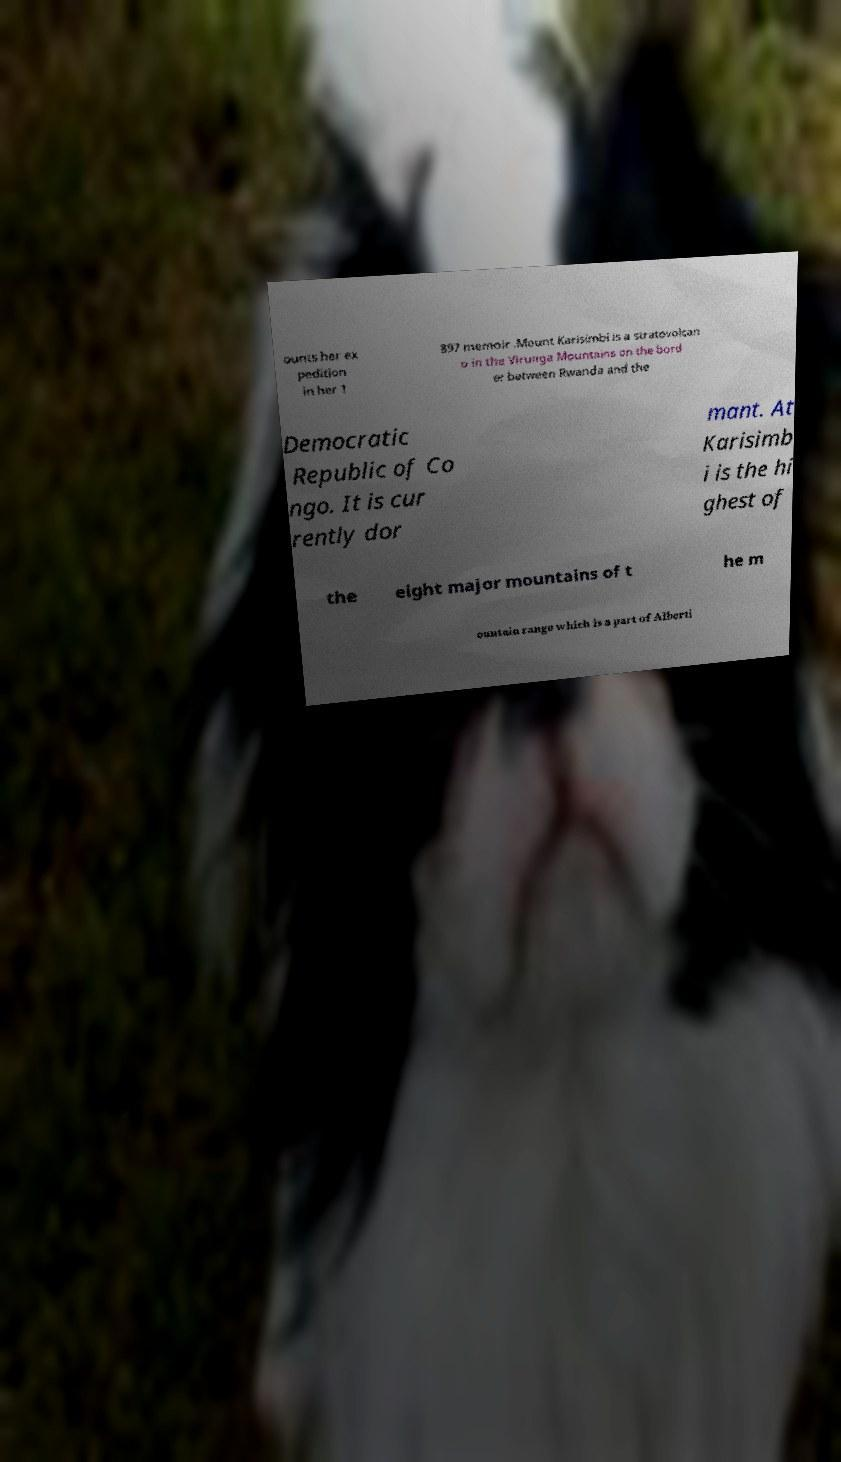Please identify and transcribe the text found in this image. ounts her ex pedition in her 1 897 memoir .Mount Karisimbi is a stratovolcan o in the Virunga Mountains on the bord er between Rwanda and the Democratic Republic of Co ngo. It is cur rently dor mant. At Karisimb i is the hi ghest of the eight major mountains of t he m ountain range which is a part of Alberti 